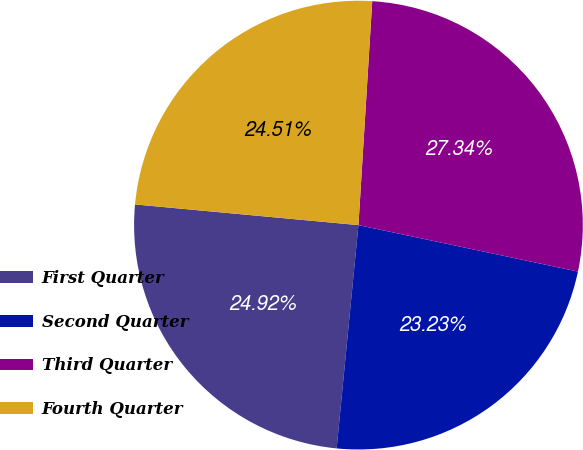Convert chart. <chart><loc_0><loc_0><loc_500><loc_500><pie_chart><fcel>First Quarter<fcel>Second Quarter<fcel>Third Quarter<fcel>Fourth Quarter<nl><fcel>24.92%<fcel>23.23%<fcel>27.34%<fcel>24.51%<nl></chart> 